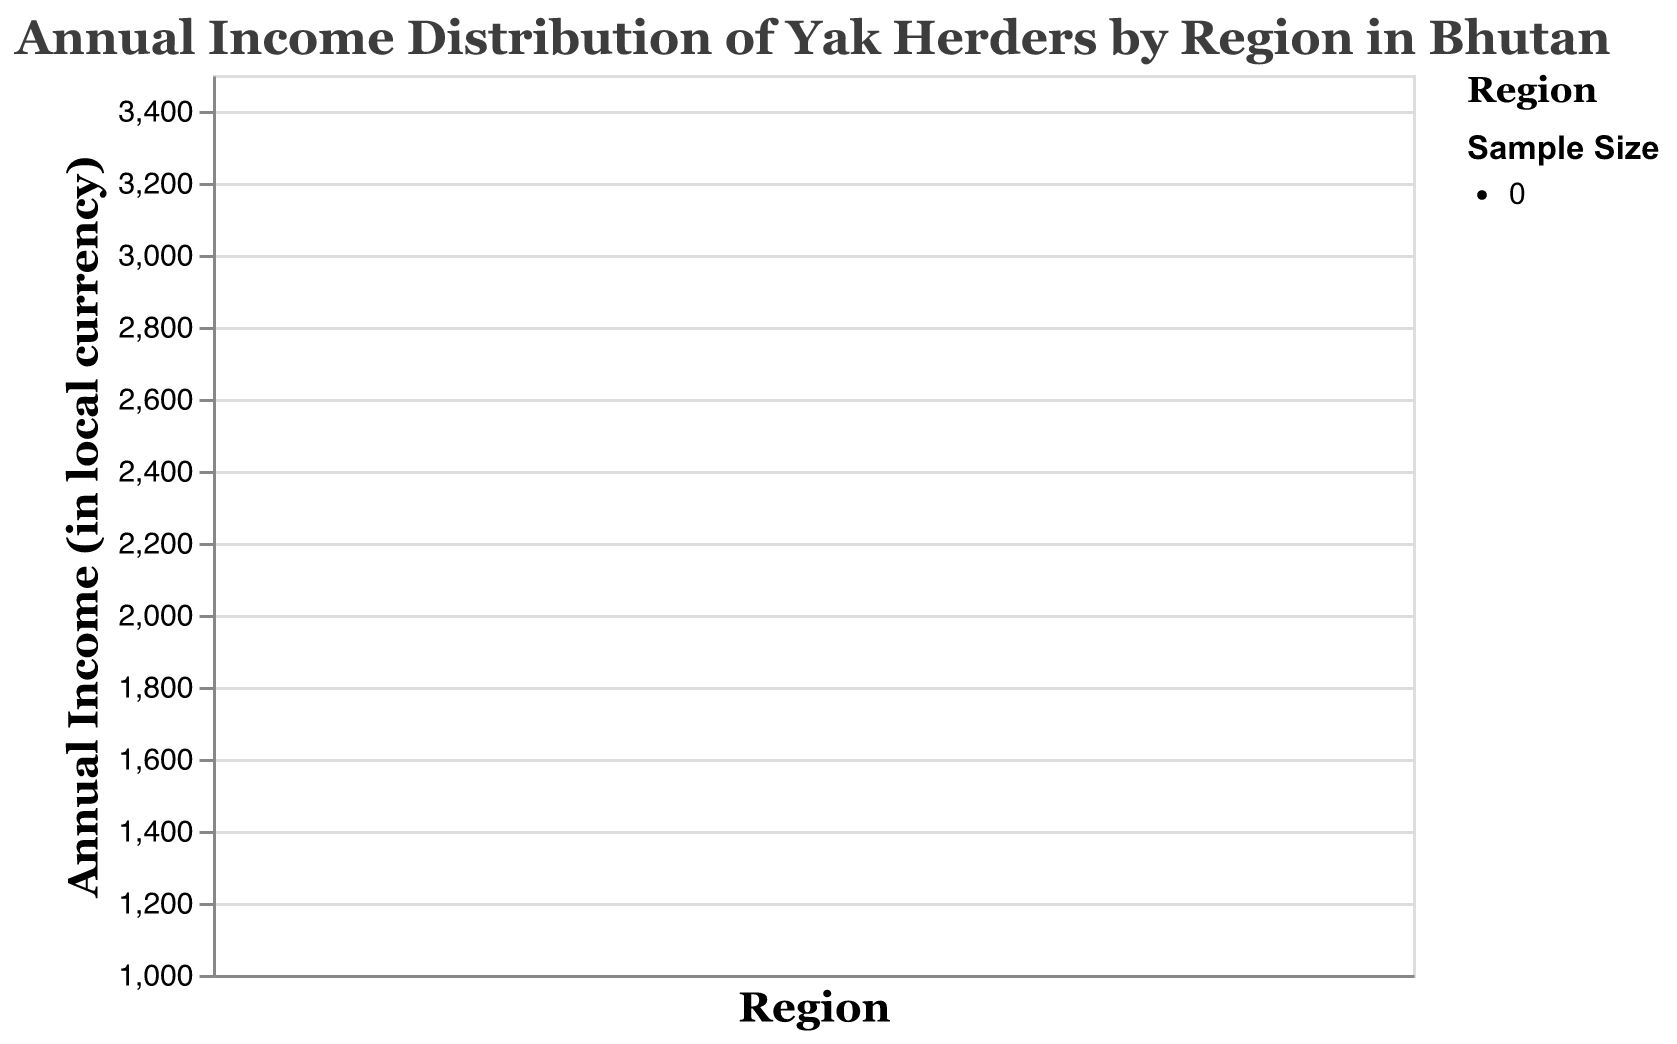What's the title of the plot? The title is located directly at the top of the figure and describes the overall theme of the plot. In this case, it reads: "Annual Income Distribution of Yak Herders by Region in Bhutan".
Answer: Annual Income Distribution of Yak Herders by Region in Bhutan What are the regions compared in the plot? The x-axis of the plot lists the regions being compared. Here, the regions mentioned are Haa, Paro, Bumthang, Trashigang, and Wangdue.
Answer: Haa, Paro, Bumthang, Trashigang, Wangdue What is the range of incomes for yak herders in Haa? By observing the specific boxplot for Haa, the lowest income value is around 1800, and the highest is approximately 2500.
Answer: 1800 to 2500 Which region has the highest median annual income? The median is represented by the thick horizontal line in the middle of each box. In this plot, Paro has the highest median income. The median for Paro is higher than the medians for the other regions.
Answer: Paro What is the median income for yak herders in Bumthang? The median in each boxplot is indicated by a black line. For Bumthang, this median line is located at approximately 1600.
Answer: 1600 Which region shows the widest range of annual incomes? The range of income is determined by the distance between the minimum and maximum points (whiskers) of the boxplots. Paro has the widest spread, ranging from about 2800 to 3300.
Answer: Paro How does the median income in Wangdue compare with that in Trashigang? To compare, we look at the black median lines in the boxplots for Wangdue and Trashigang. Wangdue's median is approximately at 2250 while Trashigang's median is around 2650. Therefore, Trashigang has a higher median income.
Answer: Wangdue's median is lower than Trashigang's What is the interquartile range (IQR) for incomes in Paro? The interquartile range (IQR) is the middle 50% of the data, represented by the height of the box itself. For Paro, the IQR spans from about 3000 to 3150.
Answer: 150 Which region shows the smallest variation in income? Variation is indicated by the length of the box and whiskers. Bumthang's boxplot shows the smallest range, with incomes ranging from about 1400 to 1800.
Answer: Bumthang In which region are the incomes most tightly clustered around the median? The clustering of incomes around the median can be assessed by how close the box (IQR) and whiskers are to the median line. Bumthang's incomes are most tightly clustered, showing minimal spread around the median.
Answer: Bumthang 